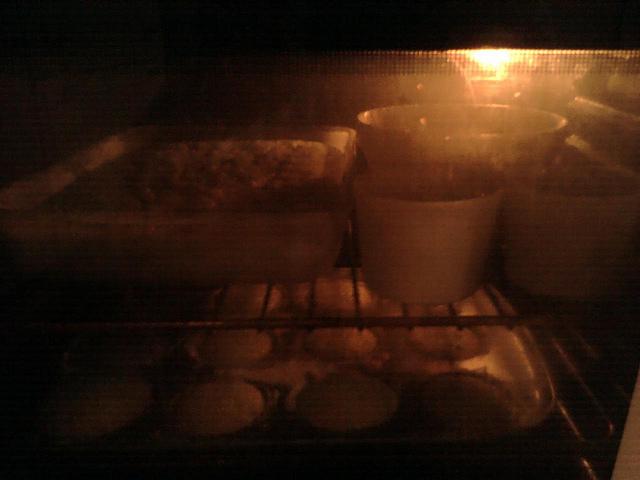Is the oven open?
Short answer required. No. Are these wrapped for "to-go"?
Be succinct. No. What is the food being cooked in?
Answer briefly. Oven. What is the person cooking?
Keep it brief. Muffins. What is cooking?
Concise answer only. Muffins. How many layers is the cake?
Quick response, please. 1. Is the pot boiling?
Short answer required. No. What kind of food is this?
Write a very short answer. Muffins. Is the oven fueled by fire?
Write a very short answer. No. Is there a light on?
Short answer required. Yes. What is the bright light in the image?
Concise answer only. Oven light. What kind of food is on the bottom rack?
Give a very brief answer. Muffins. What food is cooking in the stove?
Concise answer only. Muffins. Is there a fire in the oven?
Short answer required. No. 